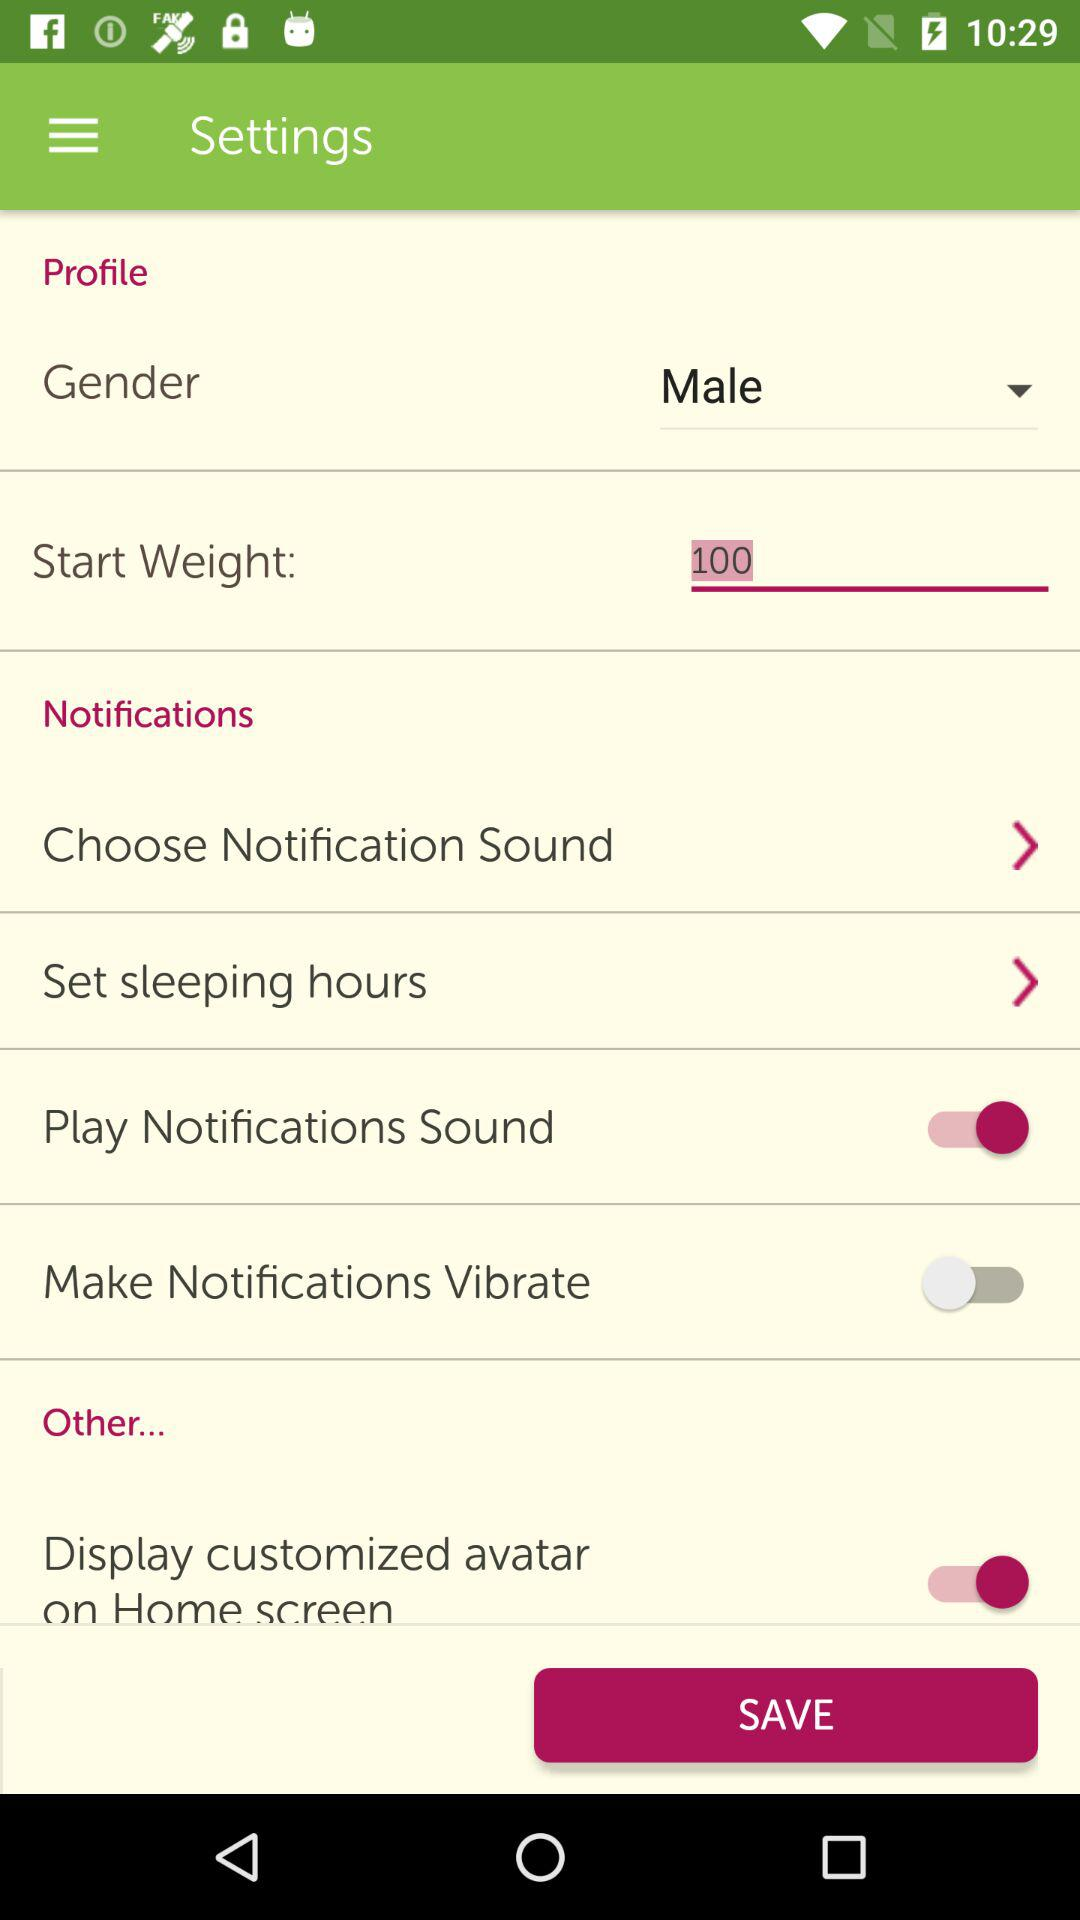Which gender is selected? The selected gender is male. 